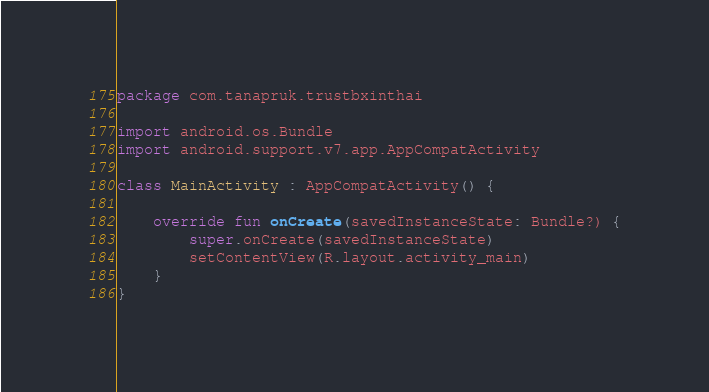Convert code to text. <code><loc_0><loc_0><loc_500><loc_500><_Kotlin_>package com.tanapruk.trustbxinthai

import android.os.Bundle
import android.support.v7.app.AppCompatActivity

class MainActivity : AppCompatActivity() {

    override fun onCreate(savedInstanceState: Bundle?) {
        super.onCreate(savedInstanceState)
        setContentView(R.layout.activity_main)
    }
}
</code> 